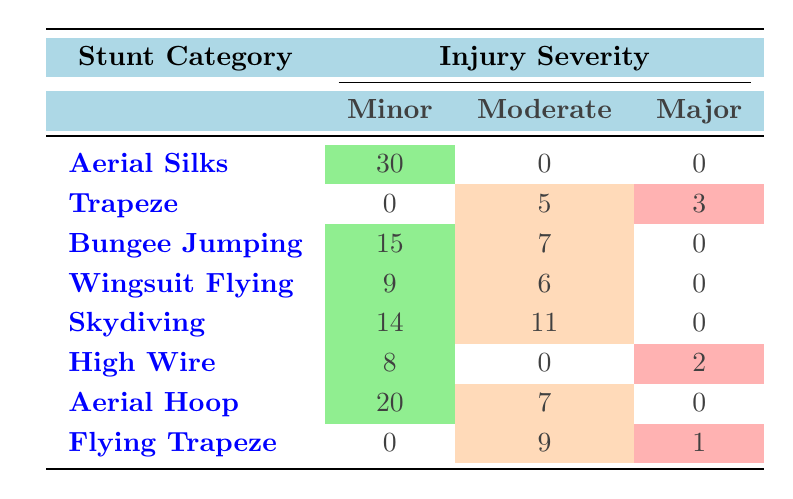What is the total number of minor injuries reported in Aerial Silks? The table shows that there are 30 minor injuries listed under Aerial Silks. Thus, the total number is directly taken from the minor injuries column in the Aerial Silks row.
Answer: 30 How many major injuries were reported across all stunt categories? The table lists major injuries as 3 for Trapeze, 2 for High Wire, and 1 for Flying Trapeze. Adding these gives 3 + 2 + 1 = 6 major injuries reported overall.
Answer: 6 Which stunt category has the highest number of moderate injuries? By examining the moderate injury counts, Trapeze has 5, Bungee Jumping has 7, Wingsuit Flying has 6, Skydiving has 11, High Wire has 0, Aerial Hoop has 7, and Flying Trapeze has 9. The highest is Skydiving with 11 moderate injuries.
Answer: 11 Are there any stunt categories where no minor injuries were reported? The categories Trapeze and Flying Trapeze both have 0 minor injuries reported. Thus, the answer is yes, indicating that these categories did not have any minor injuries.
Answer: Yes What is the difference in the number of minor injuries between Aerial Hoop and Bungee Jumping? Aerial Hoop has 20 minor injuries and Bungee Jumping has 15. The difference is calculated as 20 - 15 = 5.
Answer: 5 Which injury type had the highest incident count reported in the table? By reviewing each incident count, Bruising under Aerial Hoop shows the highest count with 20 incidents. Hence, Bruising is identified as the injury type with the most incidents.
Answer: 20 If you sum all the incidents for moderate injuries, what is the total? The counts for moderate injuries are 5 for Trapeze, 7 for Bungee Jumping, 6 for Wingsuit Flying, 11 for Skydiving, 0 for High Wire, 7 for Aerial Hoop, and 9 for Flying Trapeze. Summing these gives 5 + 7 + 6 + 11 + 0 + 7 + 9 = 45 moderate injuries.
Answer: 45 In which age group did the highest count of minor injuries occur? To determine the age group with the highest minor injuries, we can add up the counts for each age group across all stunt categories. The 25-34 age group has (12 + 15 + 8 + 14 + 0 + 20) = 69, whereas others are lower. So, 25-34 is the highest.
Answer: 25-34 Is there a stunt category with no major injuries reported? The table indicates that both Bungee Jumping, Wingsuit Flying, Aerial Silks, and Aerial Hoop report 0 major injuries. Thus, the answer is yes.
Answer: Yes 